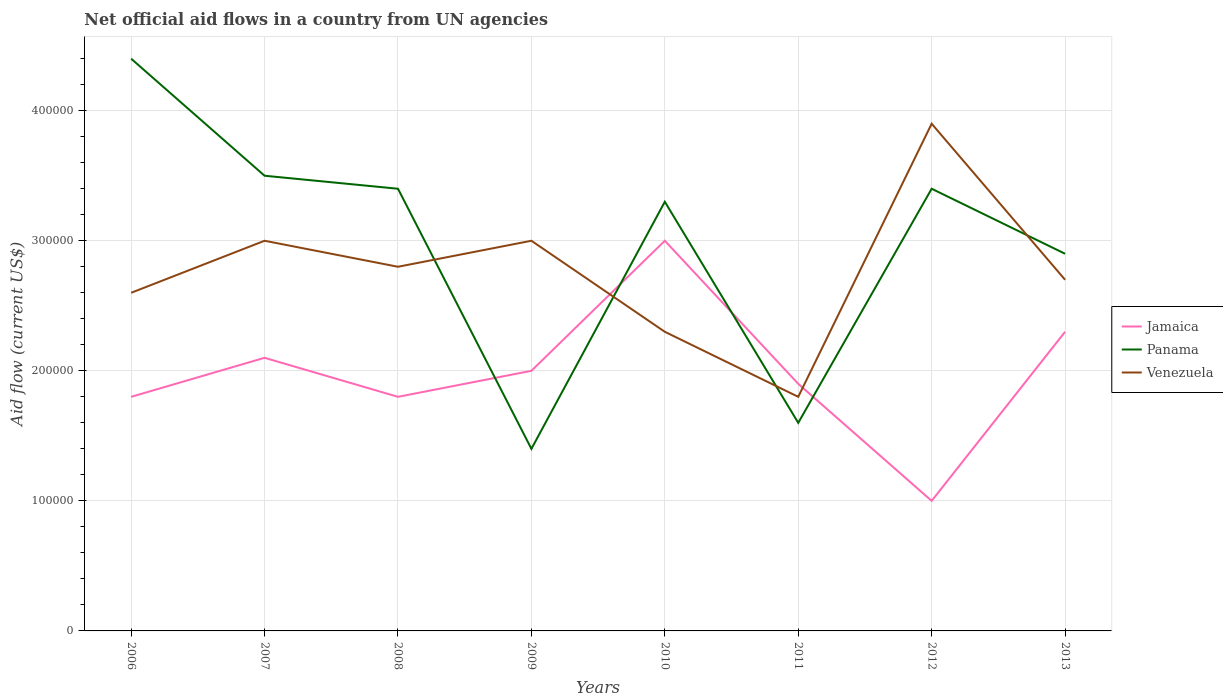Does the line corresponding to Venezuela intersect with the line corresponding to Panama?
Your answer should be very brief. Yes. Is the number of lines equal to the number of legend labels?
Your answer should be very brief. Yes. Across all years, what is the maximum net official aid flow in Jamaica?
Offer a very short reply. 1.00e+05. What is the total net official aid flow in Venezuela in the graph?
Provide a short and direct response. -1.10e+05. What is the difference between the highest and the second highest net official aid flow in Panama?
Your answer should be very brief. 3.00e+05. What is the difference between two consecutive major ticks on the Y-axis?
Your answer should be compact. 1.00e+05. Does the graph contain any zero values?
Give a very brief answer. No. Does the graph contain grids?
Your answer should be compact. Yes. How many legend labels are there?
Provide a succinct answer. 3. What is the title of the graph?
Your answer should be very brief. Net official aid flows in a country from UN agencies. What is the label or title of the X-axis?
Ensure brevity in your answer.  Years. What is the label or title of the Y-axis?
Your answer should be very brief. Aid flow (current US$). What is the Aid flow (current US$) in Jamaica in 2006?
Offer a very short reply. 1.80e+05. What is the Aid flow (current US$) of Panama in 2006?
Give a very brief answer. 4.40e+05. What is the Aid flow (current US$) in Panama in 2007?
Make the answer very short. 3.50e+05. What is the Aid flow (current US$) of Venezuela in 2007?
Offer a very short reply. 3.00e+05. What is the Aid flow (current US$) of Jamaica in 2008?
Offer a terse response. 1.80e+05. What is the Aid flow (current US$) of Panama in 2008?
Make the answer very short. 3.40e+05. What is the Aid flow (current US$) of Venezuela in 2008?
Make the answer very short. 2.80e+05. What is the Aid flow (current US$) of Panama in 2009?
Give a very brief answer. 1.40e+05. What is the Aid flow (current US$) in Venezuela in 2009?
Make the answer very short. 3.00e+05. What is the Aid flow (current US$) in Panama in 2010?
Provide a short and direct response. 3.30e+05. What is the Aid flow (current US$) in Venezuela in 2010?
Your response must be concise. 2.30e+05. What is the Aid flow (current US$) of Panama in 2012?
Make the answer very short. 3.40e+05. What is the Aid flow (current US$) of Panama in 2013?
Keep it short and to the point. 2.90e+05. What is the total Aid flow (current US$) in Jamaica in the graph?
Your answer should be very brief. 1.59e+06. What is the total Aid flow (current US$) of Panama in the graph?
Your answer should be compact. 2.39e+06. What is the total Aid flow (current US$) of Venezuela in the graph?
Provide a succinct answer. 2.21e+06. What is the difference between the Aid flow (current US$) in Jamaica in 2006 and that in 2007?
Ensure brevity in your answer.  -3.00e+04. What is the difference between the Aid flow (current US$) of Jamaica in 2006 and that in 2008?
Keep it short and to the point. 0. What is the difference between the Aid flow (current US$) in Venezuela in 2006 and that in 2008?
Provide a short and direct response. -2.00e+04. What is the difference between the Aid flow (current US$) in Venezuela in 2006 and that in 2009?
Make the answer very short. -4.00e+04. What is the difference between the Aid flow (current US$) in Venezuela in 2006 and that in 2010?
Offer a terse response. 3.00e+04. What is the difference between the Aid flow (current US$) of Panama in 2006 and that in 2012?
Keep it short and to the point. 1.00e+05. What is the difference between the Aid flow (current US$) in Venezuela in 2006 and that in 2012?
Offer a terse response. -1.30e+05. What is the difference between the Aid flow (current US$) of Jamaica in 2006 and that in 2013?
Your answer should be compact. -5.00e+04. What is the difference between the Aid flow (current US$) of Panama in 2006 and that in 2013?
Your answer should be compact. 1.50e+05. What is the difference between the Aid flow (current US$) in Venezuela in 2007 and that in 2008?
Make the answer very short. 2.00e+04. What is the difference between the Aid flow (current US$) in Venezuela in 2007 and that in 2009?
Provide a succinct answer. 0. What is the difference between the Aid flow (current US$) in Jamaica in 2007 and that in 2010?
Your response must be concise. -9.00e+04. What is the difference between the Aid flow (current US$) of Venezuela in 2007 and that in 2010?
Your response must be concise. 7.00e+04. What is the difference between the Aid flow (current US$) of Jamaica in 2007 and that in 2011?
Keep it short and to the point. 2.00e+04. What is the difference between the Aid flow (current US$) in Panama in 2007 and that in 2011?
Make the answer very short. 1.90e+05. What is the difference between the Aid flow (current US$) of Venezuela in 2007 and that in 2011?
Your response must be concise. 1.20e+05. What is the difference between the Aid flow (current US$) in Venezuela in 2007 and that in 2012?
Provide a short and direct response. -9.00e+04. What is the difference between the Aid flow (current US$) in Jamaica in 2007 and that in 2013?
Make the answer very short. -2.00e+04. What is the difference between the Aid flow (current US$) in Venezuela in 2007 and that in 2013?
Provide a short and direct response. 3.00e+04. What is the difference between the Aid flow (current US$) in Panama in 2008 and that in 2009?
Offer a terse response. 2.00e+05. What is the difference between the Aid flow (current US$) of Jamaica in 2008 and that in 2010?
Ensure brevity in your answer.  -1.20e+05. What is the difference between the Aid flow (current US$) in Venezuela in 2008 and that in 2011?
Offer a very short reply. 1.00e+05. What is the difference between the Aid flow (current US$) in Jamaica in 2008 and that in 2012?
Give a very brief answer. 8.00e+04. What is the difference between the Aid flow (current US$) in Panama in 2008 and that in 2012?
Keep it short and to the point. 0. What is the difference between the Aid flow (current US$) in Venezuela in 2008 and that in 2012?
Ensure brevity in your answer.  -1.10e+05. What is the difference between the Aid flow (current US$) in Jamaica in 2008 and that in 2013?
Your answer should be very brief. -5.00e+04. What is the difference between the Aid flow (current US$) in Panama in 2009 and that in 2010?
Your response must be concise. -1.90e+05. What is the difference between the Aid flow (current US$) in Jamaica in 2009 and that in 2011?
Provide a short and direct response. 10000. What is the difference between the Aid flow (current US$) in Jamaica in 2009 and that in 2012?
Your answer should be compact. 1.00e+05. What is the difference between the Aid flow (current US$) of Jamaica in 2010 and that in 2011?
Keep it short and to the point. 1.10e+05. What is the difference between the Aid flow (current US$) of Venezuela in 2010 and that in 2011?
Offer a very short reply. 5.00e+04. What is the difference between the Aid flow (current US$) of Jamaica in 2010 and that in 2012?
Your response must be concise. 2.00e+05. What is the difference between the Aid flow (current US$) of Panama in 2010 and that in 2012?
Provide a short and direct response. -10000. What is the difference between the Aid flow (current US$) of Venezuela in 2010 and that in 2012?
Offer a terse response. -1.60e+05. What is the difference between the Aid flow (current US$) of Jamaica in 2010 and that in 2013?
Keep it short and to the point. 7.00e+04. What is the difference between the Aid flow (current US$) in Panama in 2010 and that in 2013?
Provide a short and direct response. 4.00e+04. What is the difference between the Aid flow (current US$) of Venezuela in 2010 and that in 2013?
Provide a succinct answer. -4.00e+04. What is the difference between the Aid flow (current US$) in Panama in 2011 and that in 2012?
Offer a very short reply. -1.80e+05. What is the difference between the Aid flow (current US$) of Venezuela in 2011 and that in 2012?
Offer a very short reply. -2.10e+05. What is the difference between the Aid flow (current US$) in Jamaica in 2006 and the Aid flow (current US$) in Panama in 2007?
Provide a short and direct response. -1.70e+05. What is the difference between the Aid flow (current US$) of Panama in 2006 and the Aid flow (current US$) of Venezuela in 2008?
Your answer should be very brief. 1.60e+05. What is the difference between the Aid flow (current US$) in Jamaica in 2006 and the Aid flow (current US$) in Panama in 2009?
Provide a short and direct response. 4.00e+04. What is the difference between the Aid flow (current US$) in Jamaica in 2006 and the Aid flow (current US$) in Venezuela in 2009?
Your answer should be compact. -1.20e+05. What is the difference between the Aid flow (current US$) in Jamaica in 2006 and the Aid flow (current US$) in Panama in 2010?
Provide a succinct answer. -1.50e+05. What is the difference between the Aid flow (current US$) of Jamaica in 2006 and the Aid flow (current US$) of Venezuela in 2010?
Keep it short and to the point. -5.00e+04. What is the difference between the Aid flow (current US$) of Jamaica in 2006 and the Aid flow (current US$) of Panama in 2011?
Your answer should be very brief. 2.00e+04. What is the difference between the Aid flow (current US$) in Jamaica in 2006 and the Aid flow (current US$) in Panama in 2012?
Keep it short and to the point. -1.60e+05. What is the difference between the Aid flow (current US$) in Jamaica in 2006 and the Aid flow (current US$) in Venezuela in 2012?
Your response must be concise. -2.10e+05. What is the difference between the Aid flow (current US$) in Jamaica in 2007 and the Aid flow (current US$) in Panama in 2008?
Make the answer very short. -1.30e+05. What is the difference between the Aid flow (current US$) of Panama in 2007 and the Aid flow (current US$) of Venezuela in 2008?
Your response must be concise. 7.00e+04. What is the difference between the Aid flow (current US$) of Jamaica in 2007 and the Aid flow (current US$) of Venezuela in 2009?
Offer a terse response. -9.00e+04. What is the difference between the Aid flow (current US$) in Panama in 2007 and the Aid flow (current US$) in Venezuela in 2009?
Your answer should be compact. 5.00e+04. What is the difference between the Aid flow (current US$) of Jamaica in 2007 and the Aid flow (current US$) of Panama in 2010?
Provide a short and direct response. -1.20e+05. What is the difference between the Aid flow (current US$) in Jamaica in 2007 and the Aid flow (current US$) in Venezuela in 2010?
Provide a succinct answer. -2.00e+04. What is the difference between the Aid flow (current US$) of Jamaica in 2007 and the Aid flow (current US$) of Panama in 2011?
Make the answer very short. 5.00e+04. What is the difference between the Aid flow (current US$) in Jamaica in 2007 and the Aid flow (current US$) in Venezuela in 2011?
Your answer should be very brief. 3.00e+04. What is the difference between the Aid flow (current US$) in Jamaica in 2007 and the Aid flow (current US$) in Venezuela in 2012?
Make the answer very short. -1.80e+05. What is the difference between the Aid flow (current US$) of Panama in 2007 and the Aid flow (current US$) of Venezuela in 2012?
Make the answer very short. -4.00e+04. What is the difference between the Aid flow (current US$) of Jamaica in 2007 and the Aid flow (current US$) of Panama in 2013?
Keep it short and to the point. -8.00e+04. What is the difference between the Aid flow (current US$) in Jamaica in 2007 and the Aid flow (current US$) in Venezuela in 2013?
Give a very brief answer. -6.00e+04. What is the difference between the Aid flow (current US$) in Panama in 2007 and the Aid flow (current US$) in Venezuela in 2013?
Your answer should be very brief. 8.00e+04. What is the difference between the Aid flow (current US$) of Jamaica in 2008 and the Aid flow (current US$) of Panama in 2010?
Your answer should be compact. -1.50e+05. What is the difference between the Aid flow (current US$) of Panama in 2008 and the Aid flow (current US$) of Venezuela in 2011?
Make the answer very short. 1.60e+05. What is the difference between the Aid flow (current US$) of Jamaica in 2008 and the Aid flow (current US$) of Panama in 2012?
Provide a short and direct response. -1.60e+05. What is the difference between the Aid flow (current US$) of Jamaica in 2008 and the Aid flow (current US$) of Venezuela in 2012?
Your response must be concise. -2.10e+05. What is the difference between the Aid flow (current US$) of Jamaica in 2009 and the Aid flow (current US$) of Panama in 2010?
Your response must be concise. -1.30e+05. What is the difference between the Aid flow (current US$) in Panama in 2009 and the Aid flow (current US$) in Venezuela in 2010?
Offer a very short reply. -9.00e+04. What is the difference between the Aid flow (current US$) in Panama in 2009 and the Aid flow (current US$) in Venezuela in 2011?
Keep it short and to the point. -4.00e+04. What is the difference between the Aid flow (current US$) of Jamaica in 2009 and the Aid flow (current US$) of Venezuela in 2013?
Give a very brief answer. -7.00e+04. What is the difference between the Aid flow (current US$) in Panama in 2009 and the Aid flow (current US$) in Venezuela in 2013?
Your answer should be very brief. -1.30e+05. What is the difference between the Aid flow (current US$) of Jamaica in 2010 and the Aid flow (current US$) of Venezuela in 2011?
Keep it short and to the point. 1.20e+05. What is the difference between the Aid flow (current US$) in Panama in 2010 and the Aid flow (current US$) in Venezuela in 2011?
Make the answer very short. 1.50e+05. What is the difference between the Aid flow (current US$) in Jamaica in 2010 and the Aid flow (current US$) in Panama in 2012?
Ensure brevity in your answer.  -4.00e+04. What is the difference between the Aid flow (current US$) of Panama in 2010 and the Aid flow (current US$) of Venezuela in 2012?
Your answer should be very brief. -6.00e+04. What is the difference between the Aid flow (current US$) in Jamaica in 2010 and the Aid flow (current US$) in Panama in 2013?
Give a very brief answer. 10000. What is the difference between the Aid flow (current US$) of Jamaica in 2011 and the Aid flow (current US$) of Panama in 2012?
Your answer should be very brief. -1.50e+05. What is the difference between the Aid flow (current US$) of Panama in 2011 and the Aid flow (current US$) of Venezuela in 2012?
Make the answer very short. -2.30e+05. What is the difference between the Aid flow (current US$) in Jamaica in 2011 and the Aid flow (current US$) in Panama in 2013?
Provide a short and direct response. -1.00e+05. What is the difference between the Aid flow (current US$) of Panama in 2011 and the Aid flow (current US$) of Venezuela in 2013?
Keep it short and to the point. -1.10e+05. What is the average Aid flow (current US$) of Jamaica per year?
Keep it short and to the point. 1.99e+05. What is the average Aid flow (current US$) of Panama per year?
Give a very brief answer. 2.99e+05. What is the average Aid flow (current US$) of Venezuela per year?
Provide a succinct answer. 2.76e+05. In the year 2006, what is the difference between the Aid flow (current US$) in Jamaica and Aid flow (current US$) in Panama?
Your response must be concise. -2.60e+05. In the year 2006, what is the difference between the Aid flow (current US$) in Panama and Aid flow (current US$) in Venezuela?
Ensure brevity in your answer.  1.80e+05. In the year 2007, what is the difference between the Aid flow (current US$) in Jamaica and Aid flow (current US$) in Panama?
Offer a very short reply. -1.40e+05. In the year 2009, what is the difference between the Aid flow (current US$) of Panama and Aid flow (current US$) of Venezuela?
Your response must be concise. -1.60e+05. In the year 2010, what is the difference between the Aid flow (current US$) in Jamaica and Aid flow (current US$) in Panama?
Your response must be concise. -3.00e+04. In the year 2010, what is the difference between the Aid flow (current US$) in Jamaica and Aid flow (current US$) in Venezuela?
Offer a very short reply. 7.00e+04. In the year 2010, what is the difference between the Aid flow (current US$) in Panama and Aid flow (current US$) in Venezuela?
Make the answer very short. 1.00e+05. In the year 2011, what is the difference between the Aid flow (current US$) of Jamaica and Aid flow (current US$) of Panama?
Keep it short and to the point. 3.00e+04. In the year 2011, what is the difference between the Aid flow (current US$) in Panama and Aid flow (current US$) in Venezuela?
Provide a succinct answer. -2.00e+04. In the year 2013, what is the difference between the Aid flow (current US$) of Jamaica and Aid flow (current US$) of Panama?
Keep it short and to the point. -6.00e+04. In the year 2013, what is the difference between the Aid flow (current US$) in Jamaica and Aid flow (current US$) in Venezuela?
Keep it short and to the point. -4.00e+04. What is the ratio of the Aid flow (current US$) of Panama in 2006 to that in 2007?
Make the answer very short. 1.26. What is the ratio of the Aid flow (current US$) in Venezuela in 2006 to that in 2007?
Your response must be concise. 0.87. What is the ratio of the Aid flow (current US$) of Panama in 2006 to that in 2008?
Provide a succinct answer. 1.29. What is the ratio of the Aid flow (current US$) in Jamaica in 2006 to that in 2009?
Give a very brief answer. 0.9. What is the ratio of the Aid flow (current US$) in Panama in 2006 to that in 2009?
Your answer should be very brief. 3.14. What is the ratio of the Aid flow (current US$) in Venezuela in 2006 to that in 2009?
Provide a short and direct response. 0.87. What is the ratio of the Aid flow (current US$) in Jamaica in 2006 to that in 2010?
Give a very brief answer. 0.6. What is the ratio of the Aid flow (current US$) in Panama in 2006 to that in 2010?
Give a very brief answer. 1.33. What is the ratio of the Aid flow (current US$) of Venezuela in 2006 to that in 2010?
Ensure brevity in your answer.  1.13. What is the ratio of the Aid flow (current US$) of Panama in 2006 to that in 2011?
Keep it short and to the point. 2.75. What is the ratio of the Aid flow (current US$) of Venezuela in 2006 to that in 2011?
Offer a very short reply. 1.44. What is the ratio of the Aid flow (current US$) of Panama in 2006 to that in 2012?
Your answer should be compact. 1.29. What is the ratio of the Aid flow (current US$) of Venezuela in 2006 to that in 2012?
Provide a succinct answer. 0.67. What is the ratio of the Aid flow (current US$) in Jamaica in 2006 to that in 2013?
Your response must be concise. 0.78. What is the ratio of the Aid flow (current US$) in Panama in 2006 to that in 2013?
Offer a very short reply. 1.52. What is the ratio of the Aid flow (current US$) in Venezuela in 2006 to that in 2013?
Make the answer very short. 0.96. What is the ratio of the Aid flow (current US$) of Panama in 2007 to that in 2008?
Your response must be concise. 1.03. What is the ratio of the Aid flow (current US$) in Venezuela in 2007 to that in 2008?
Provide a succinct answer. 1.07. What is the ratio of the Aid flow (current US$) of Jamaica in 2007 to that in 2009?
Keep it short and to the point. 1.05. What is the ratio of the Aid flow (current US$) in Venezuela in 2007 to that in 2009?
Your answer should be compact. 1. What is the ratio of the Aid flow (current US$) of Jamaica in 2007 to that in 2010?
Offer a terse response. 0.7. What is the ratio of the Aid flow (current US$) in Panama in 2007 to that in 2010?
Your answer should be compact. 1.06. What is the ratio of the Aid flow (current US$) in Venezuela in 2007 to that in 2010?
Your response must be concise. 1.3. What is the ratio of the Aid flow (current US$) in Jamaica in 2007 to that in 2011?
Your answer should be very brief. 1.11. What is the ratio of the Aid flow (current US$) in Panama in 2007 to that in 2011?
Keep it short and to the point. 2.19. What is the ratio of the Aid flow (current US$) of Venezuela in 2007 to that in 2011?
Provide a succinct answer. 1.67. What is the ratio of the Aid flow (current US$) in Panama in 2007 to that in 2012?
Keep it short and to the point. 1.03. What is the ratio of the Aid flow (current US$) in Venezuela in 2007 to that in 2012?
Make the answer very short. 0.77. What is the ratio of the Aid flow (current US$) of Jamaica in 2007 to that in 2013?
Offer a very short reply. 0.91. What is the ratio of the Aid flow (current US$) in Panama in 2007 to that in 2013?
Your answer should be very brief. 1.21. What is the ratio of the Aid flow (current US$) of Jamaica in 2008 to that in 2009?
Give a very brief answer. 0.9. What is the ratio of the Aid flow (current US$) in Panama in 2008 to that in 2009?
Your answer should be compact. 2.43. What is the ratio of the Aid flow (current US$) in Venezuela in 2008 to that in 2009?
Make the answer very short. 0.93. What is the ratio of the Aid flow (current US$) in Panama in 2008 to that in 2010?
Give a very brief answer. 1.03. What is the ratio of the Aid flow (current US$) of Venezuela in 2008 to that in 2010?
Offer a terse response. 1.22. What is the ratio of the Aid flow (current US$) in Panama in 2008 to that in 2011?
Offer a terse response. 2.12. What is the ratio of the Aid flow (current US$) of Venezuela in 2008 to that in 2011?
Keep it short and to the point. 1.56. What is the ratio of the Aid flow (current US$) in Jamaica in 2008 to that in 2012?
Your answer should be compact. 1.8. What is the ratio of the Aid flow (current US$) of Venezuela in 2008 to that in 2012?
Your response must be concise. 0.72. What is the ratio of the Aid flow (current US$) of Jamaica in 2008 to that in 2013?
Offer a terse response. 0.78. What is the ratio of the Aid flow (current US$) of Panama in 2008 to that in 2013?
Your response must be concise. 1.17. What is the ratio of the Aid flow (current US$) of Venezuela in 2008 to that in 2013?
Offer a terse response. 1.04. What is the ratio of the Aid flow (current US$) of Panama in 2009 to that in 2010?
Your answer should be very brief. 0.42. What is the ratio of the Aid flow (current US$) of Venezuela in 2009 to that in 2010?
Make the answer very short. 1.3. What is the ratio of the Aid flow (current US$) in Jamaica in 2009 to that in 2011?
Ensure brevity in your answer.  1.05. What is the ratio of the Aid flow (current US$) in Panama in 2009 to that in 2011?
Provide a succinct answer. 0.88. What is the ratio of the Aid flow (current US$) in Jamaica in 2009 to that in 2012?
Your response must be concise. 2. What is the ratio of the Aid flow (current US$) in Panama in 2009 to that in 2012?
Give a very brief answer. 0.41. What is the ratio of the Aid flow (current US$) of Venezuela in 2009 to that in 2012?
Your answer should be very brief. 0.77. What is the ratio of the Aid flow (current US$) of Jamaica in 2009 to that in 2013?
Provide a succinct answer. 0.87. What is the ratio of the Aid flow (current US$) of Panama in 2009 to that in 2013?
Ensure brevity in your answer.  0.48. What is the ratio of the Aid flow (current US$) in Jamaica in 2010 to that in 2011?
Make the answer very short. 1.58. What is the ratio of the Aid flow (current US$) of Panama in 2010 to that in 2011?
Provide a succinct answer. 2.06. What is the ratio of the Aid flow (current US$) in Venezuela in 2010 to that in 2011?
Make the answer very short. 1.28. What is the ratio of the Aid flow (current US$) in Jamaica in 2010 to that in 2012?
Your response must be concise. 3. What is the ratio of the Aid flow (current US$) in Panama in 2010 to that in 2012?
Offer a terse response. 0.97. What is the ratio of the Aid flow (current US$) in Venezuela in 2010 to that in 2012?
Provide a succinct answer. 0.59. What is the ratio of the Aid flow (current US$) of Jamaica in 2010 to that in 2013?
Your answer should be very brief. 1.3. What is the ratio of the Aid flow (current US$) of Panama in 2010 to that in 2013?
Make the answer very short. 1.14. What is the ratio of the Aid flow (current US$) of Venezuela in 2010 to that in 2013?
Your response must be concise. 0.85. What is the ratio of the Aid flow (current US$) in Panama in 2011 to that in 2012?
Your answer should be very brief. 0.47. What is the ratio of the Aid flow (current US$) in Venezuela in 2011 to that in 2012?
Ensure brevity in your answer.  0.46. What is the ratio of the Aid flow (current US$) of Jamaica in 2011 to that in 2013?
Your response must be concise. 0.83. What is the ratio of the Aid flow (current US$) of Panama in 2011 to that in 2013?
Your answer should be very brief. 0.55. What is the ratio of the Aid flow (current US$) of Venezuela in 2011 to that in 2013?
Offer a very short reply. 0.67. What is the ratio of the Aid flow (current US$) of Jamaica in 2012 to that in 2013?
Offer a terse response. 0.43. What is the ratio of the Aid flow (current US$) in Panama in 2012 to that in 2013?
Make the answer very short. 1.17. What is the ratio of the Aid flow (current US$) in Venezuela in 2012 to that in 2013?
Your answer should be very brief. 1.44. What is the difference between the highest and the second highest Aid flow (current US$) in Jamaica?
Your response must be concise. 7.00e+04. What is the difference between the highest and the second highest Aid flow (current US$) in Panama?
Your answer should be very brief. 9.00e+04. What is the difference between the highest and the lowest Aid flow (current US$) in Jamaica?
Your response must be concise. 2.00e+05. 